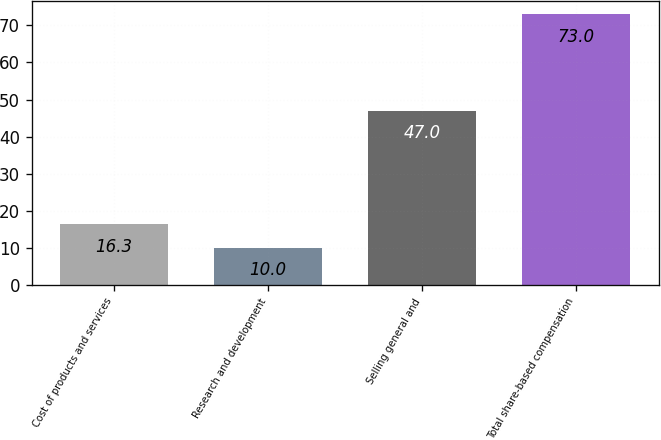<chart> <loc_0><loc_0><loc_500><loc_500><bar_chart><fcel>Cost of products and services<fcel>Research and development<fcel>Selling general and<fcel>Total share-based compensation<nl><fcel>16.3<fcel>10<fcel>47<fcel>73<nl></chart> 